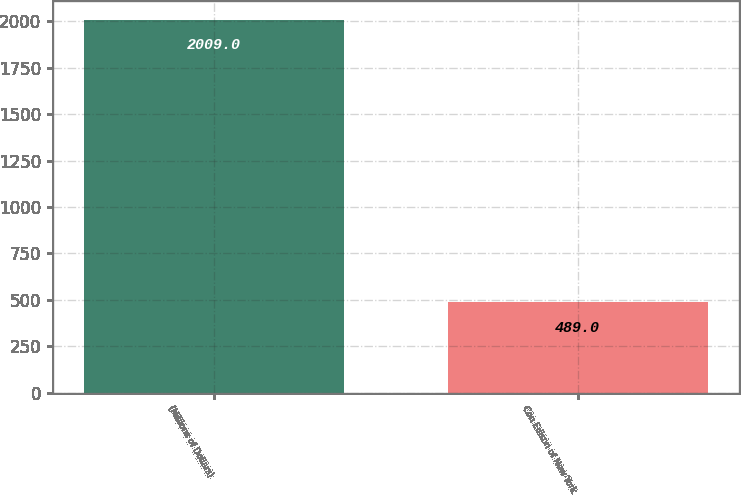<chart> <loc_0><loc_0><loc_500><loc_500><bar_chart><fcel>(Millions of Dollars)<fcel>Con Edison of New York<nl><fcel>2009<fcel>489<nl></chart> 